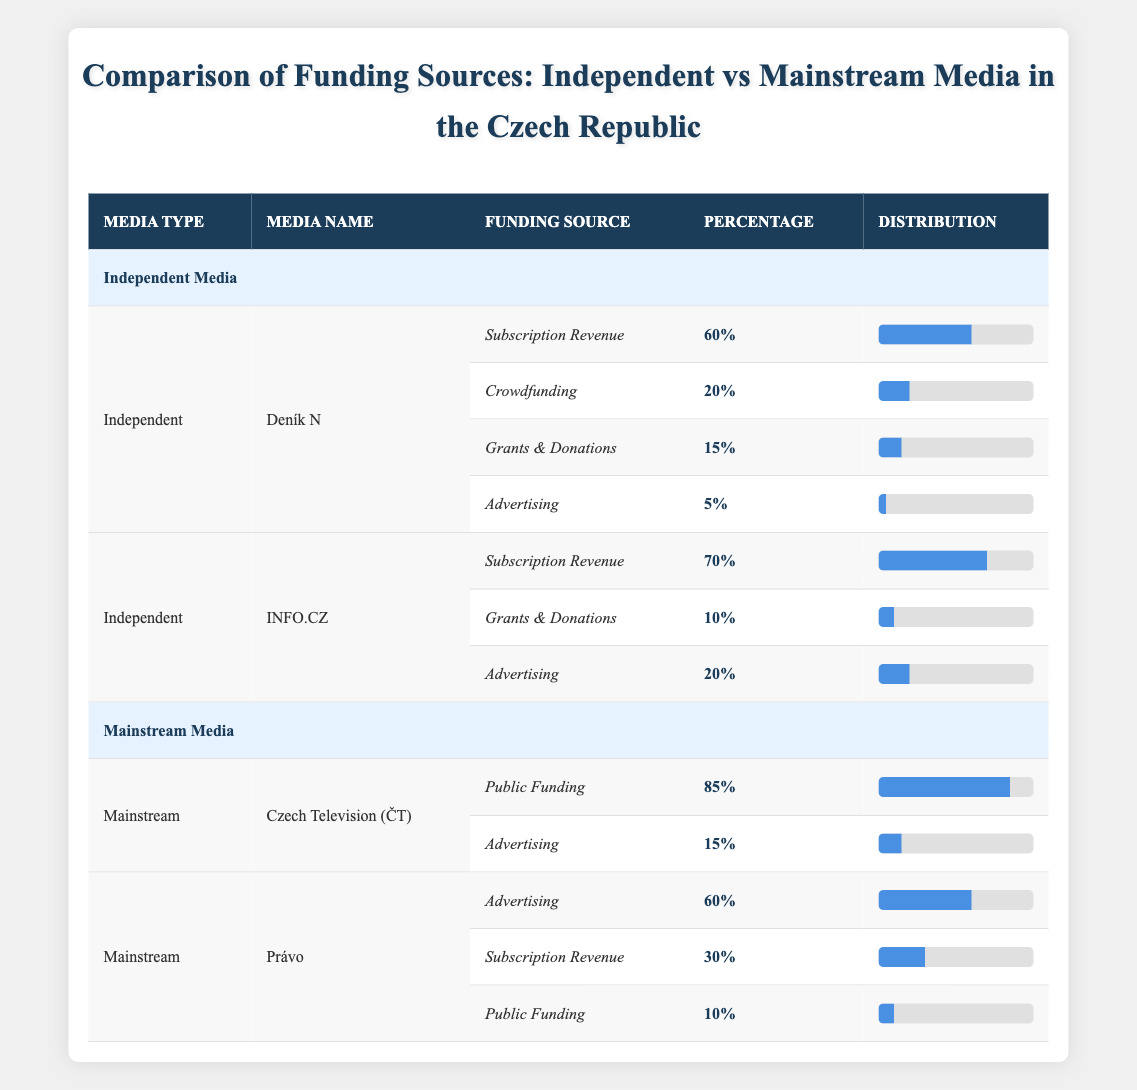What is the percentage of funding from subscription revenue for Deník N? The table lists Deník N under independent media, and within that section, the row for subscription revenue states that it accounts for 60% of its funding.
Answer: 60% Which media outlet has the highest percentage of funding from public sources? The table shows Czech Television (ČT) as having 85% of its funding from public funding, which is the highest compared to other outlets listed.
Answer: Czech Television (ČT) What is the difference in funding percentage from advertising between INFO.CZ and Právo? For INFO.CZ, advertising makes up 20% of its funding, and for Právo, it accounts for 60%. The difference is calculated as 60% - 20% = 40%.
Answer: 40% Is Deník N predominantly funded by subscription revenue? Deník N has 60% of its funding from subscription revenue, which is the largest single source of funding for the outlet compared to other sources like crowdfunding and donations. Therefore, it is accurate to say it is predominantly funded by this source.
Answer: Yes What is the total percentage of funding from subscriptions across both independent media outlets? Deník N has 60% and INFO.CZ has 70% from subscription revenue. Adding these gives us a total of 60% + 70% = 130%.
Answer: 130% Which independent media outlet relies more on crowdfunding, and what is that percentage? Deník N has 20% of its funding from crowdfunding, while INFO.CZ does not use crowdfunding at all. Thus, Deník N relies more on this source.
Answer: Deník N; 20% What is the combined percentage of public funding and advertising for Právo? Právo has 10% from public funding and 60% from advertising. Adding these percentages gives us 10% + 60% = 70%.
Answer: 70% How much of the funding for INFO.CZ comes from grants and donations? Looking at the row for INFO.CZ, it shows that grants and donations comprise 10% of its overall funding.
Answer: 10% 